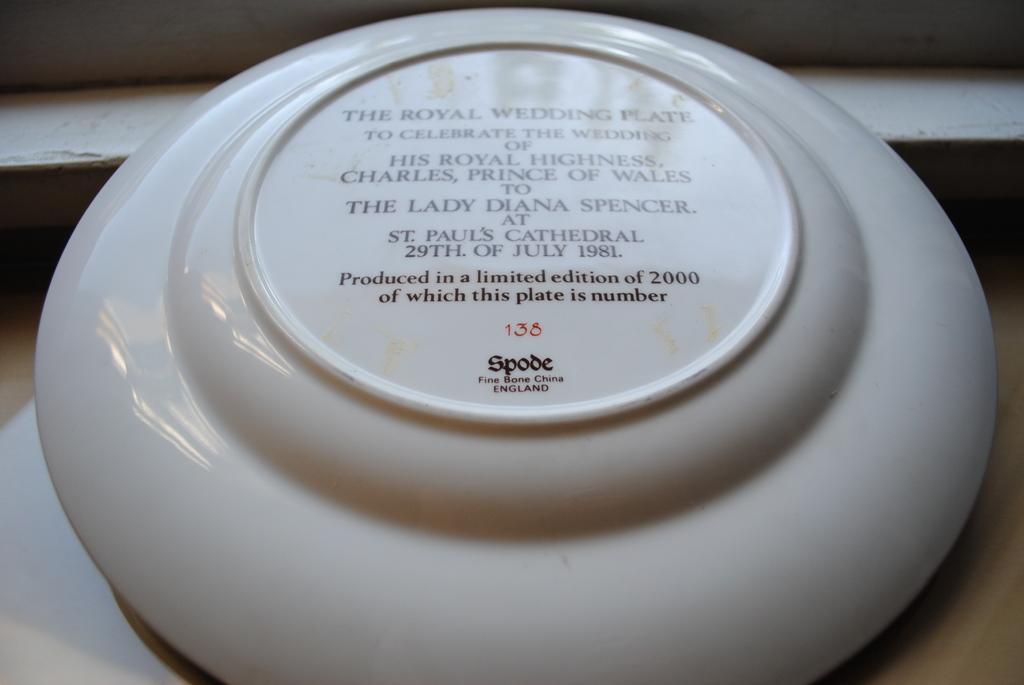Describe this image in one or two sentences. In this image we can see a plate with some text on it. 